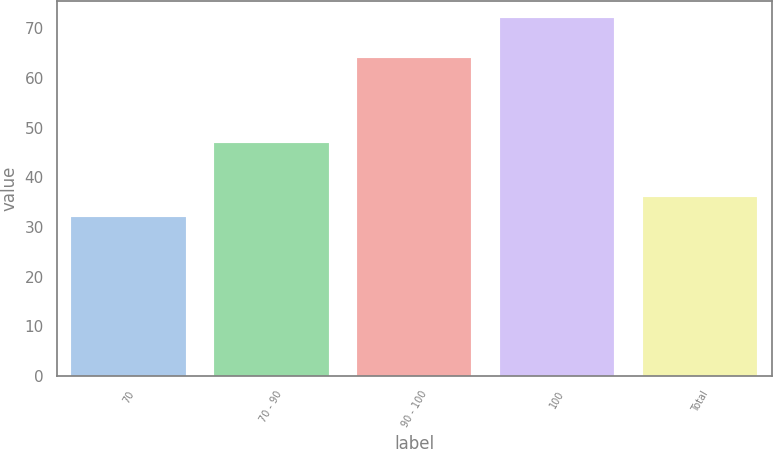Convert chart to OTSL. <chart><loc_0><loc_0><loc_500><loc_500><bar_chart><fcel>70<fcel>70 - 90<fcel>90 - 100<fcel>100<fcel>Total<nl><fcel>32<fcel>47<fcel>64<fcel>72<fcel>36<nl></chart> 